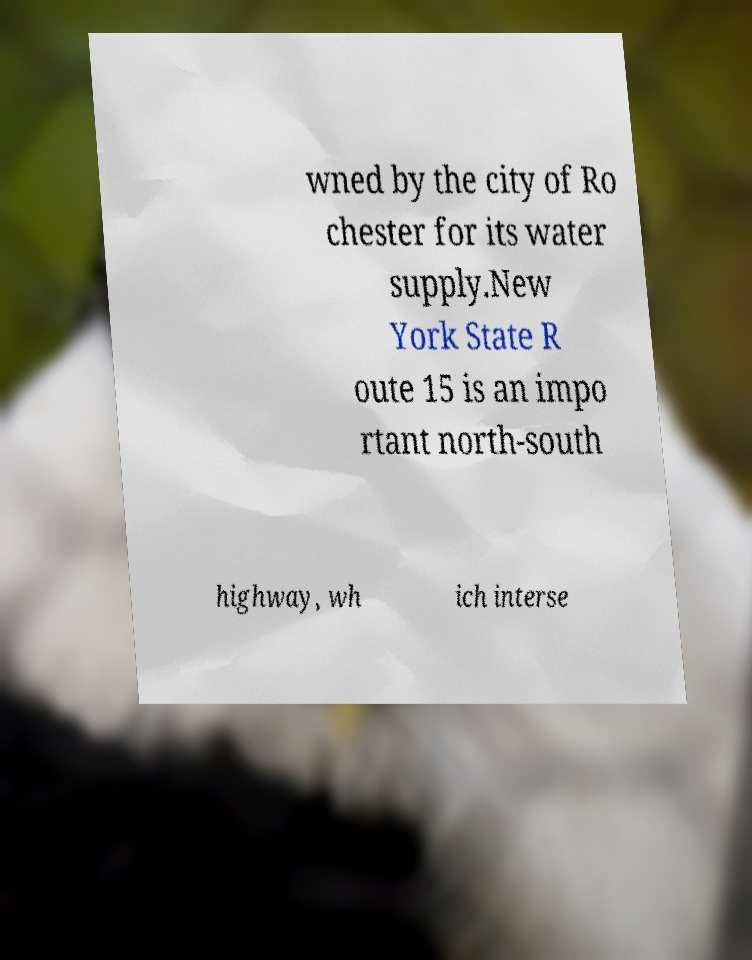Please identify and transcribe the text found in this image. wned by the city of Ro chester for its water supply.New York State R oute 15 is an impo rtant north-south highway, wh ich interse 